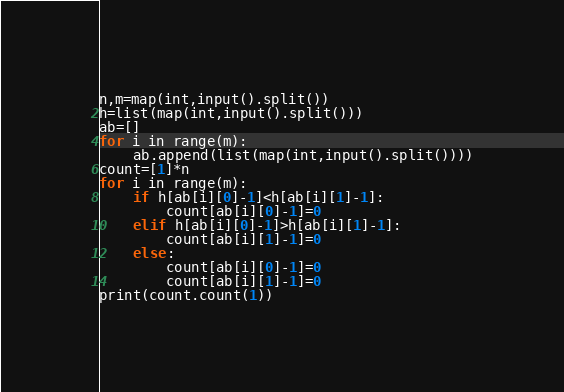<code> <loc_0><loc_0><loc_500><loc_500><_Python_>n,m=map(int,input().split())
h=list(map(int,input().split()))
ab=[]
for i in range(m):
    ab.append(list(map(int,input().split())))
count=[1]*n
for i in range(m):
    if h[ab[i][0]-1]<h[ab[i][1]-1]:
        count[ab[i][0]-1]=0
    elif h[ab[i][0]-1]>h[ab[i][1]-1]:
        count[ab[i][1]-1]=0
    else:
        count[ab[i][0]-1]=0
        count[ab[i][1]-1]=0
print(count.count(1))</code> 